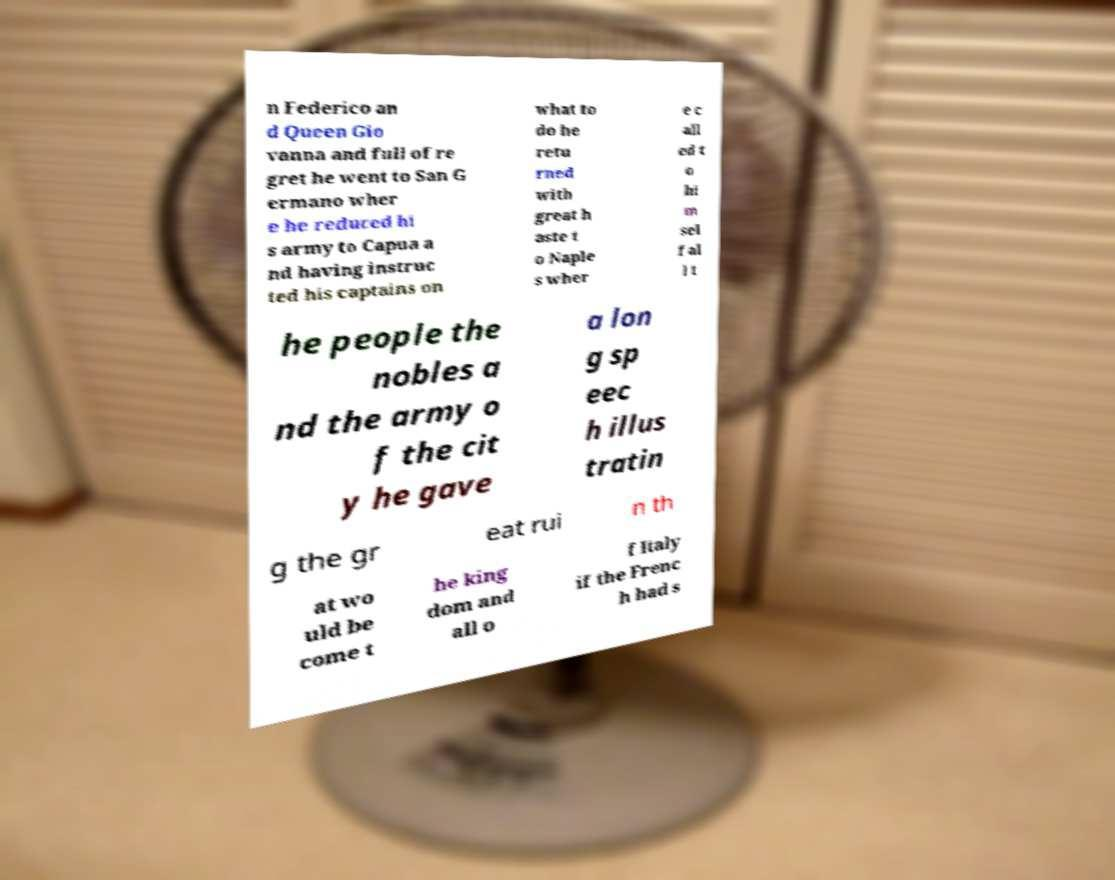There's text embedded in this image that I need extracted. Can you transcribe it verbatim? n Federico an d Queen Gio vanna and full of re gret he went to San G ermano wher e he reduced hi s army to Capua a nd having instruc ted his captains on what to do he retu rned with great h aste t o Naple s wher e c all ed t o hi m sel f al l t he people the nobles a nd the army o f the cit y he gave a lon g sp eec h illus tratin g the gr eat rui n th at wo uld be come t he king dom and all o f Italy if the Frenc h had s 